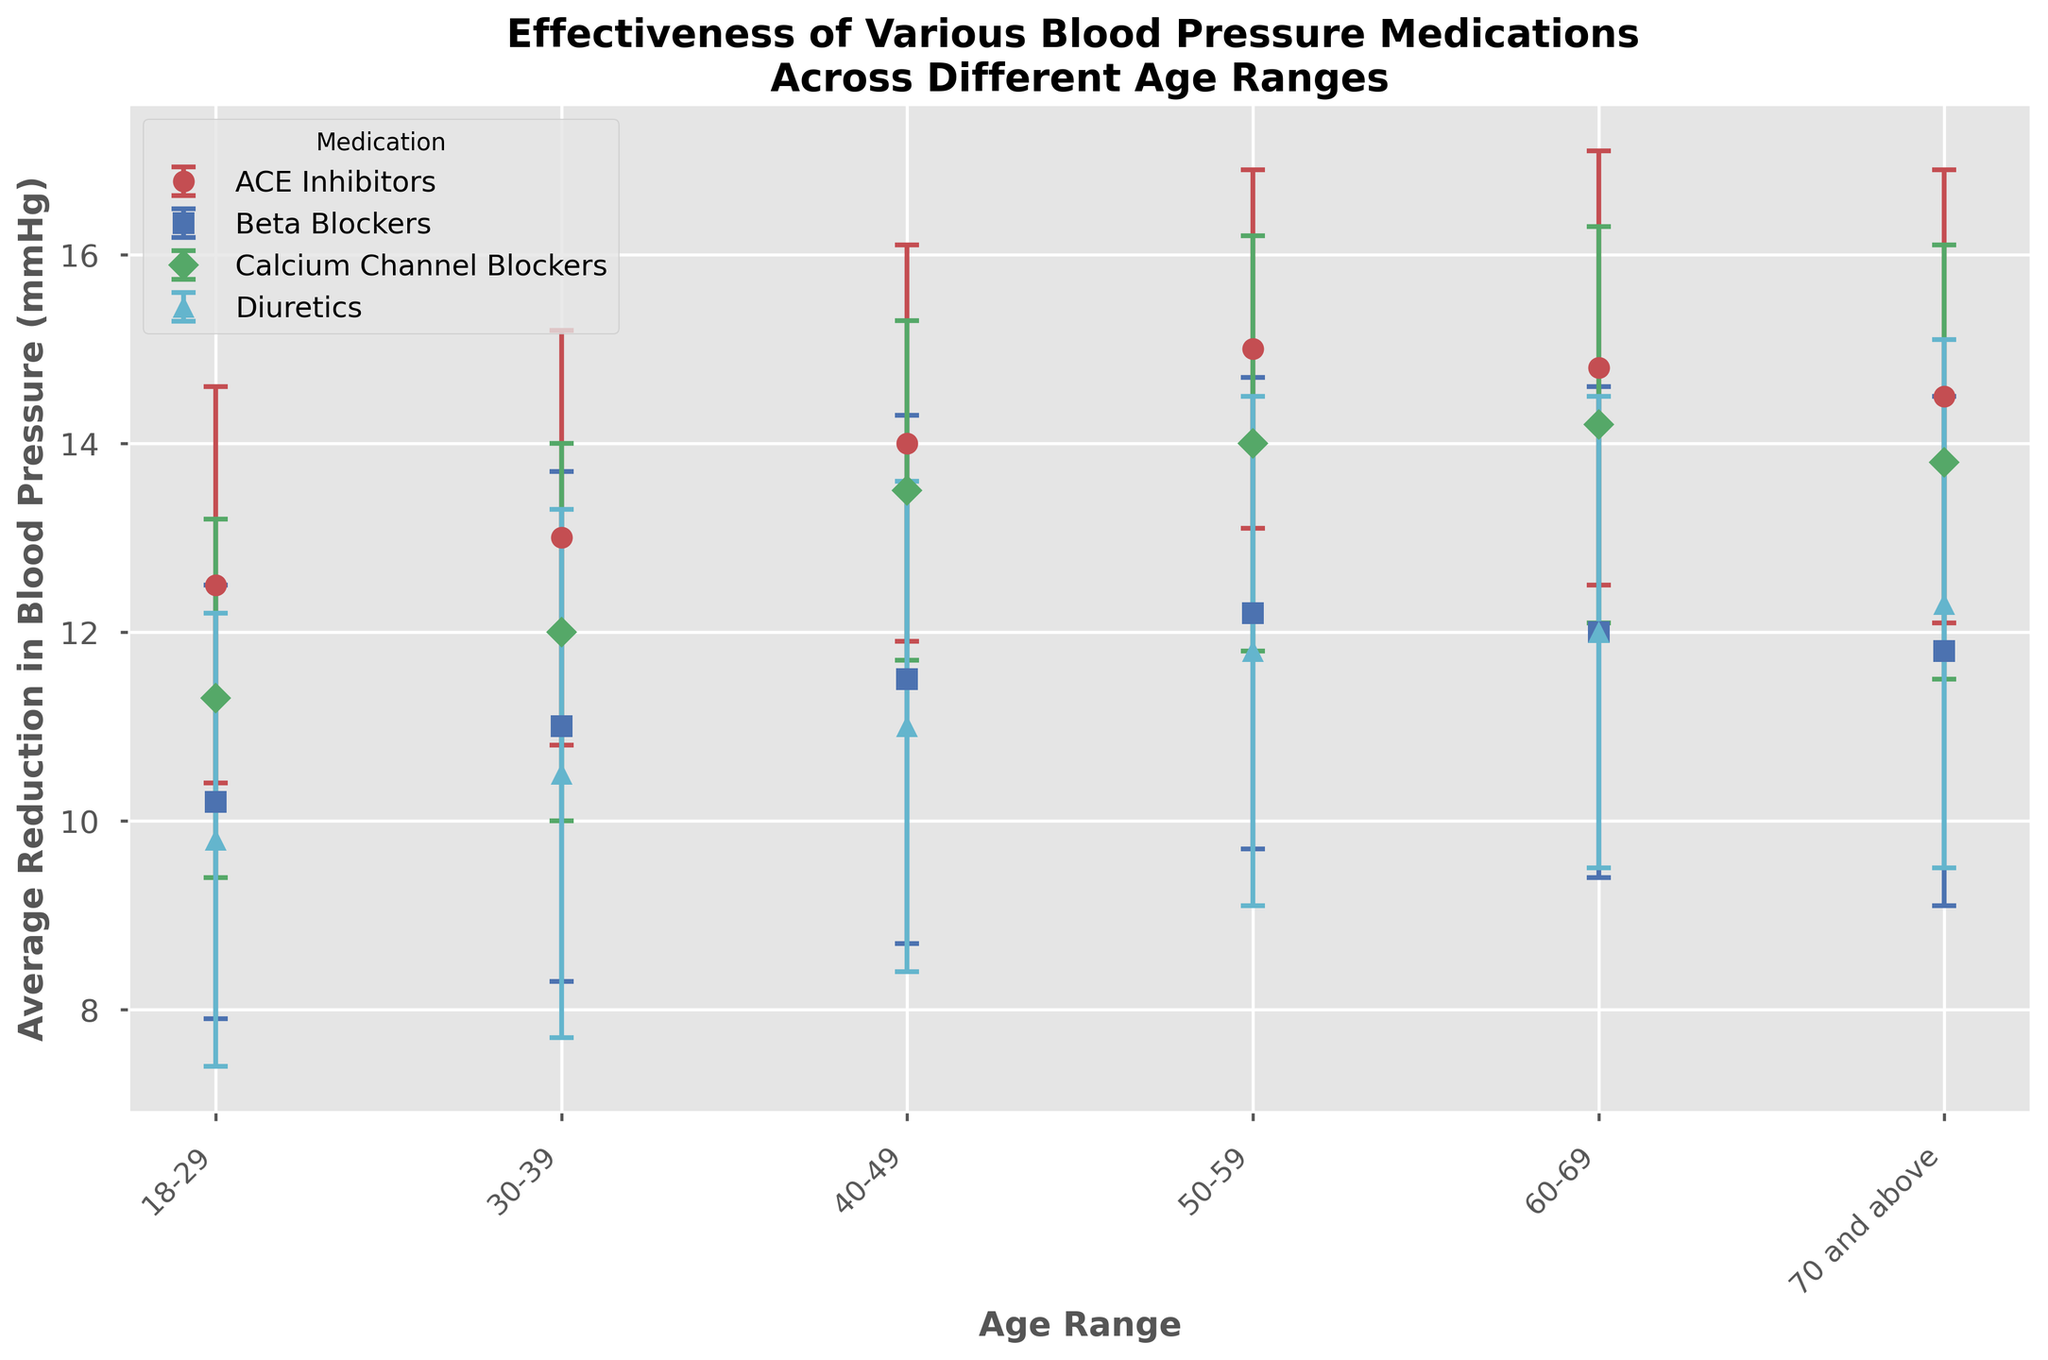Which medication shows the highest average reduction in blood pressure for the age range 40-49? Look for the medication in the 40-49 age range with the highest bar. The ACE Inhibitors show an average reduction of 14.0 mmHg.
Answer: ACE Inhibitors Which age range has the lowest average reduction in blood pressure for Beta Blockers? Compare the heights of the bars for Beta Blockers across all age ranges. The lowest average reduction is seen in the 18-29 age group with 10.2 mmHg.
Answer: 18-29 What is the difference in average blood pressure reduction between ACE Inhibitors and Diuretics for the age range 50-59? Look at the bars for ACE Inhibitors and Diuretics in the 50-59 age range. The average reduction for ACE Inhibitors is 15.0 mmHg and for Diuretics is 11.8 mmHg. The difference is 15.0 - 11.8 = 3.2 mmHg.
Answer: 3.2 mmHg Which medication shows the most consistent performance (smallest standard deviation) across all age ranges? Compare the error bars (yerr) across all medications. Calcium Channel Blockers have relatively smaller error bars most consistently.
Answer: Calcium Channel Blockers For the age range 60-69, what is the sum of the average reductions in blood pressure for ACE Inhibitors and Beta Blockers? Add the average reductions for ACE Inhibitors and Beta Blockers in the 60-69 age range. The values are 14.8 mmHg and 12.0 mmHg, respectively. Therefore, 14.8 + 12.0 = 26.8 mmHg.
Answer: 26.8 mmHg How does the effectiveness of Diuretics for ages 70 and above compare to that for ages 40-49? Compare the average reduction values for Diuretics in both age ranges. For 70 and above, the reduction is 12.3 mmHg, and for 40-49, it is 11.0 mmHg. Therefore, Diuretics are more effective in the 70 and above age group.
Answer: More effective Which medication has the highest standard deviation in the age range 30-39? Compare the error bars for each medication in the 30-39 age range. Beta Blockers have the highest standard deviation with 2.7 mmHg.
Answer: Beta Blockers What is the average reduction in blood pressure for Calcium Channel Blockers across all age ranges? Calculate the average of the reduction values for Calcium Channel Blockers: (11.3 + 12.0 + 13.5 + 14.0 + 14.2 + 13.8) / 6 = 13.13 mmHg.
Answer: 13.13 mmHg 